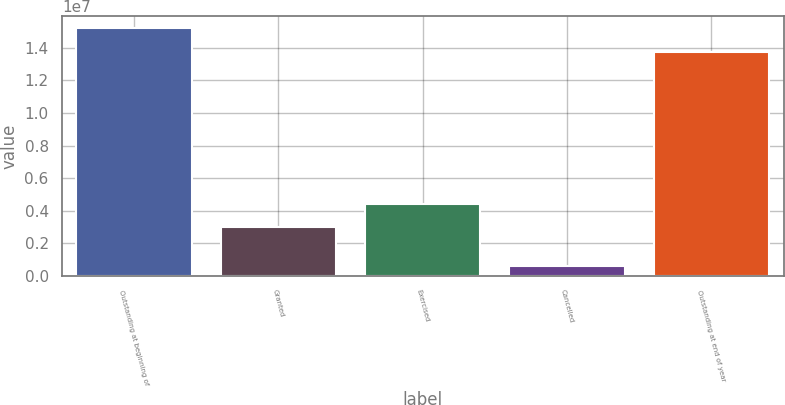Convert chart. <chart><loc_0><loc_0><loc_500><loc_500><bar_chart><fcel>Outstanding at beginning of<fcel>Granted<fcel>Exercised<fcel>Cancelled<fcel>Outstanding at end of year<nl><fcel>1.52035e+07<fcel>3.01388e+06<fcel>4.43937e+06<fcel>583022<fcel>1.3778e+07<nl></chart> 